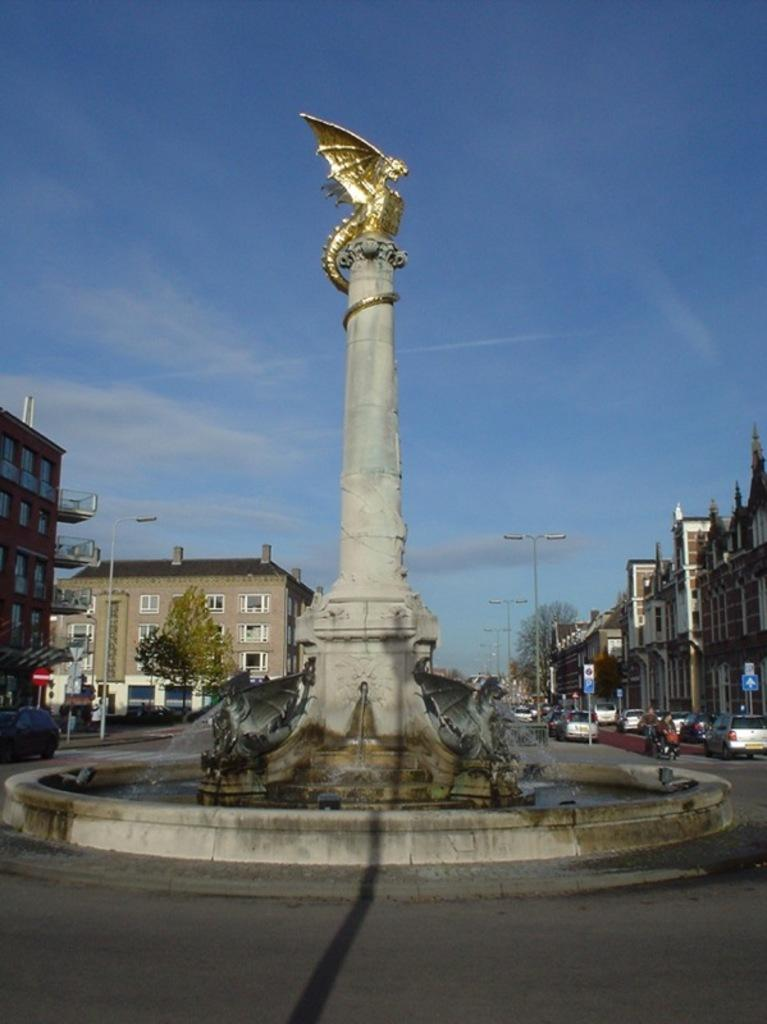What is the main structure in the middle of the image? There is a stone pillar in the middle of the image. What is on top of the stone pillar? There is a golden dragon on top of the pillar. What can be seen in the distance behind the stone pillar? There are buildings visible in the background. How are vehicles positioned around the stone pillar? Cars are parked around the stone pillar. Where can the toad be found in the image? There is no toad present in the image. What type of animals can be seen at the zoo in the image? There is no zoo present in the image. 